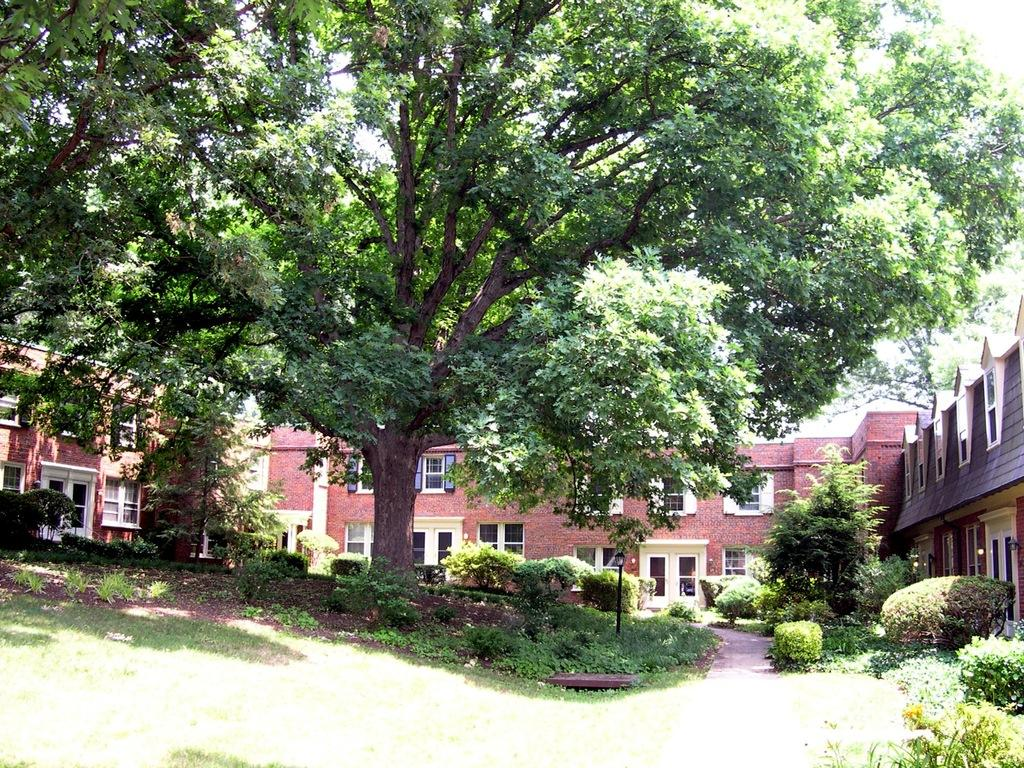What type of vegetation is present on the ground in the image? There is grass and plants on the ground in the image. What can be seen in the background of the image? There are trees and a building in the background of the image. How many plastic bees are sitting on the plot in the image? There is no mention of a plot or plastic bees in the image; it features grass, plants, trees, and a building. 